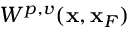Convert formula to latex. <formula><loc_0><loc_0><loc_500><loc_500>W ^ { p , v } ( { x } , { x } _ { F } )</formula> 